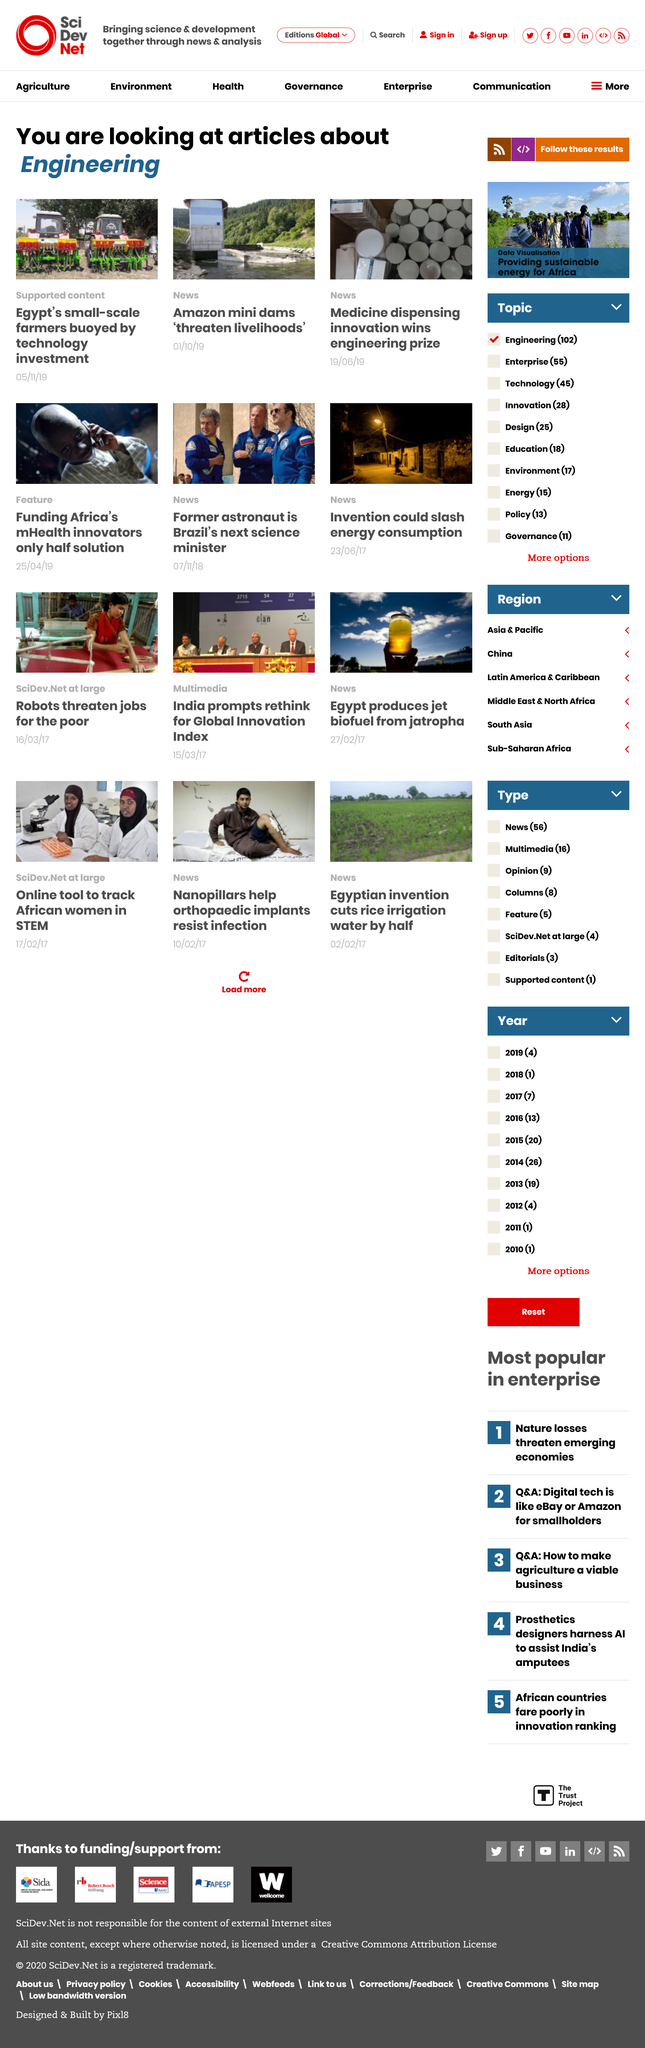Outline some significant characteristics in this image. Egypt's small-scale farmers have been buoyed by technology investment, thus becoming a source of strength for the country's agricultural sector. The articles mentioned pertain to the subject of engineering and contain information about it. A groundbreaking innovation in medicine dispensing has been recognized with a prestigious engineering prize. 